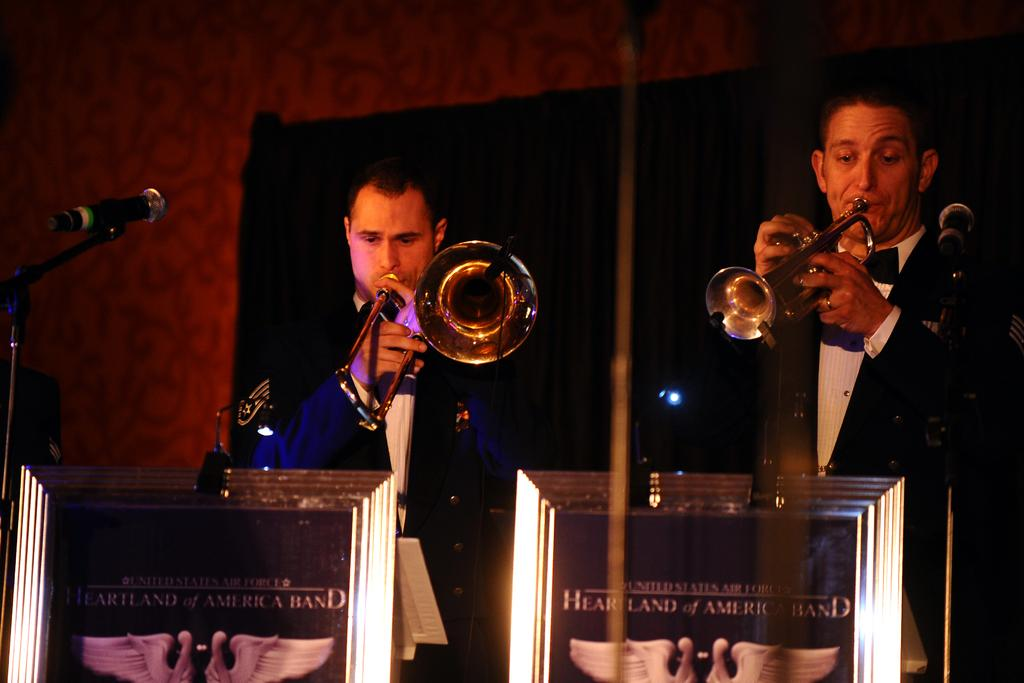What are the people in the image wearing? The people in the image are wearing black suits. What are the people in the black suits doing? They are playing trumpets. Where are the people in the black suits positioned? They are in front of a dias. What can be seen behind the people in the image? There is a hall behind them. What is on the left side of the image? There is a mic on the left side of the image. What type of comb is being used to style the hair of the person in the image? There is no person visible in the image, and therefore no hair or comb can be observed. What flavor of soda is being served in the image? There is no soda present in the image. 